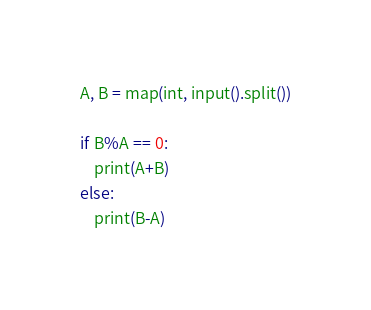<code> <loc_0><loc_0><loc_500><loc_500><_Python_>A, B = map(int, input().split())

if B%A == 0:
    print(A+B)
else:
    print(B-A)</code> 